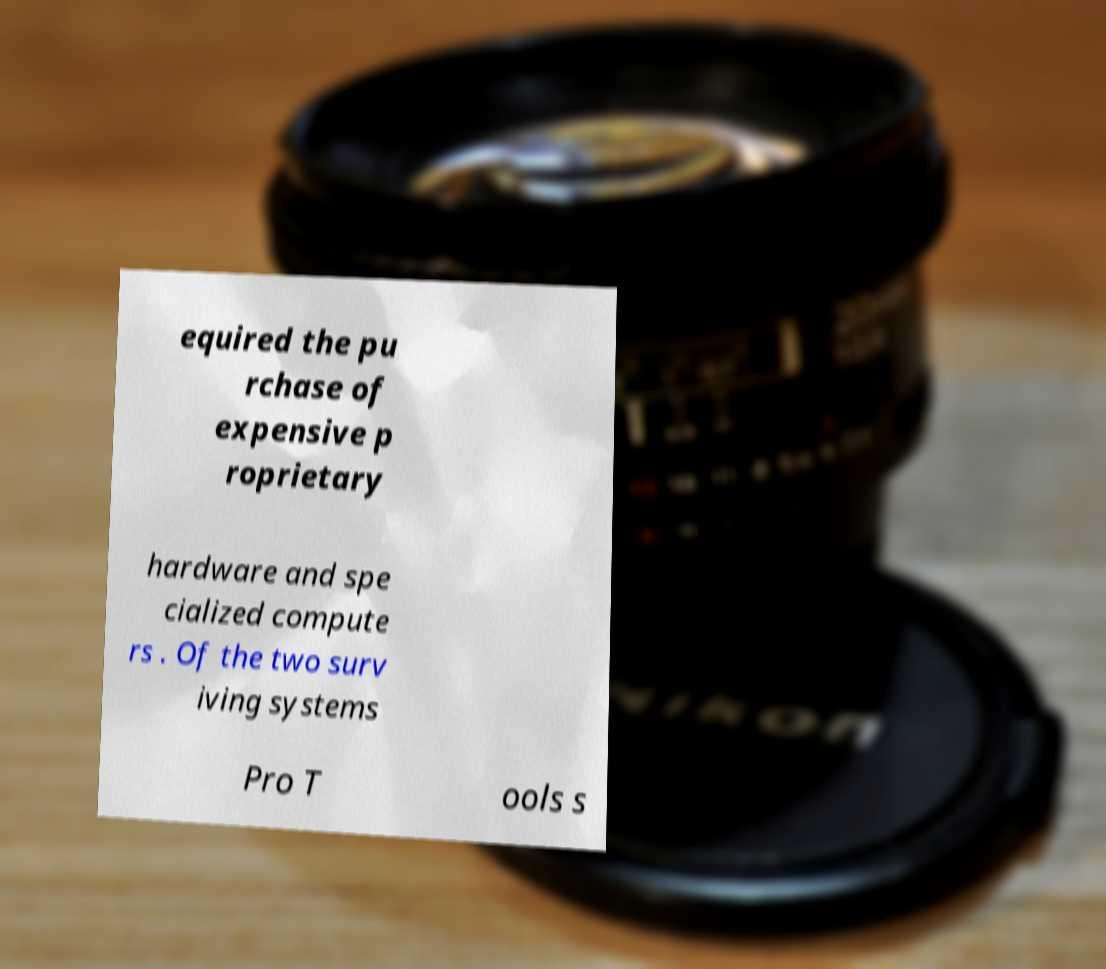What messages or text are displayed in this image? I need them in a readable, typed format. equired the pu rchase of expensive p roprietary hardware and spe cialized compute rs . Of the two surv iving systems Pro T ools s 